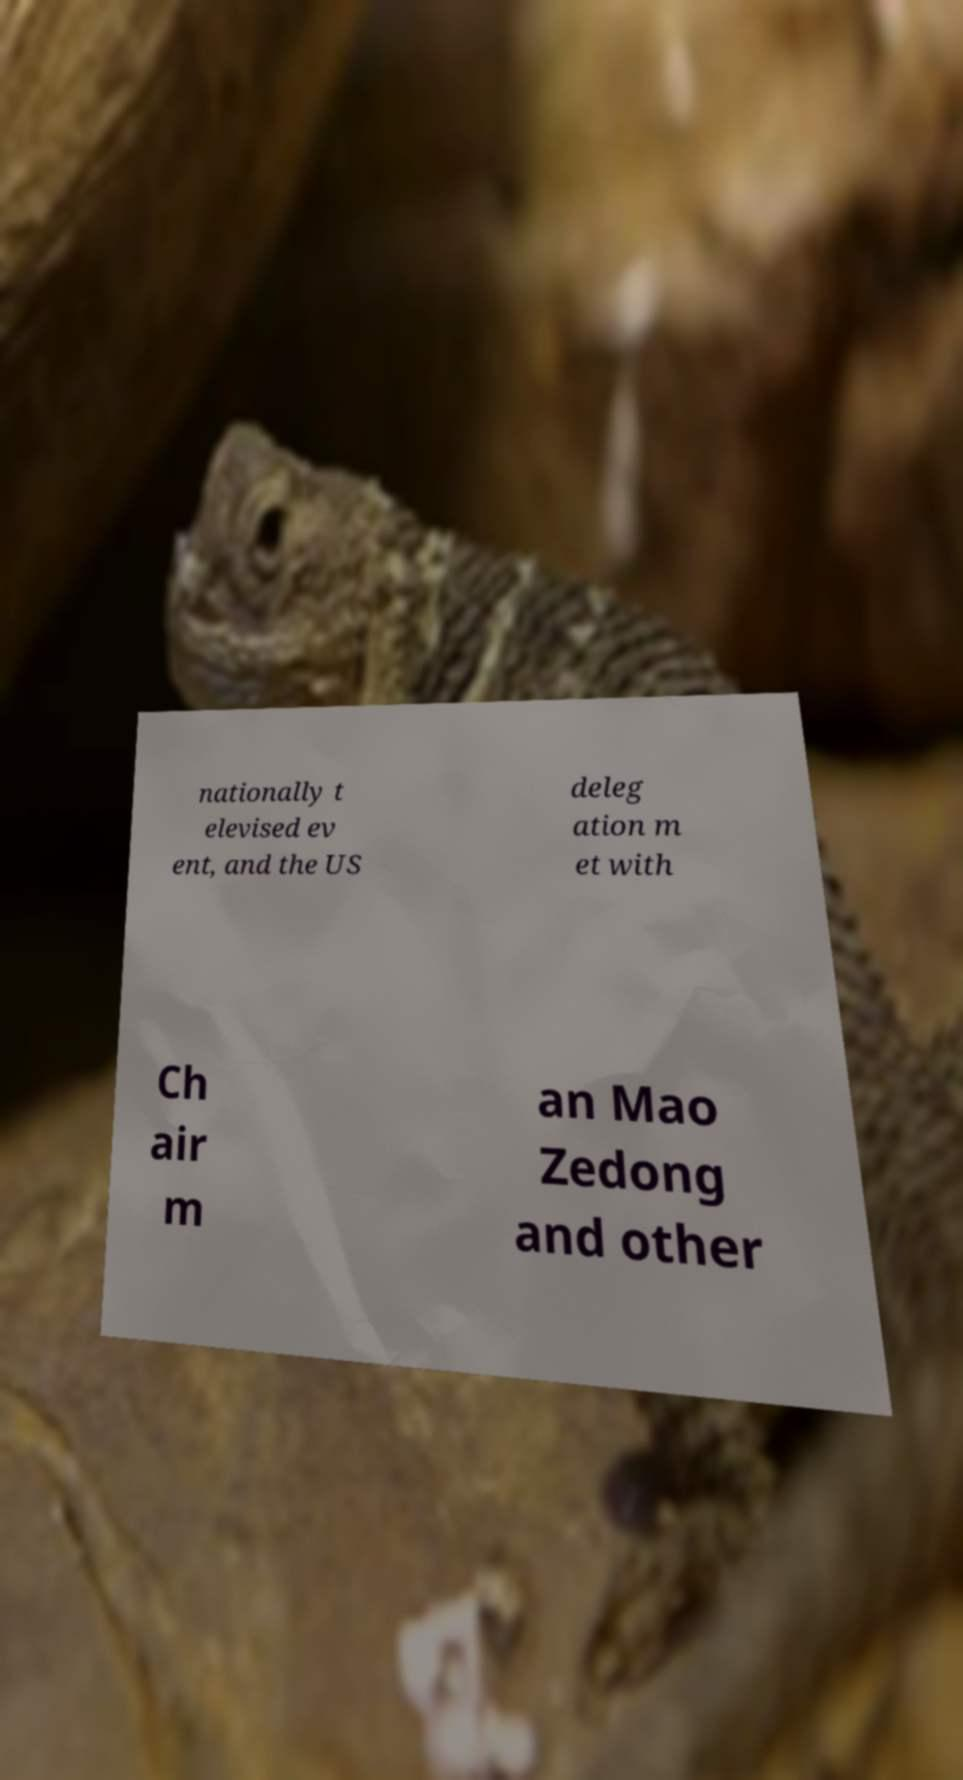For documentation purposes, I need the text within this image transcribed. Could you provide that? nationally t elevised ev ent, and the US deleg ation m et with Ch air m an Mao Zedong and other 